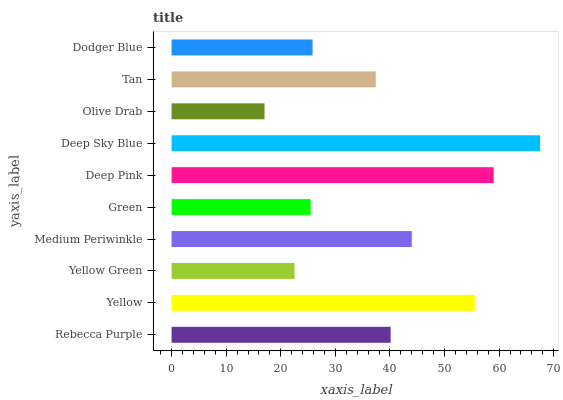Is Olive Drab the minimum?
Answer yes or no. Yes. Is Deep Sky Blue the maximum?
Answer yes or no. Yes. Is Yellow the minimum?
Answer yes or no. No. Is Yellow the maximum?
Answer yes or no. No. Is Yellow greater than Rebecca Purple?
Answer yes or no. Yes. Is Rebecca Purple less than Yellow?
Answer yes or no. Yes. Is Rebecca Purple greater than Yellow?
Answer yes or no. No. Is Yellow less than Rebecca Purple?
Answer yes or no. No. Is Rebecca Purple the high median?
Answer yes or no. Yes. Is Tan the low median?
Answer yes or no. Yes. Is Tan the high median?
Answer yes or no. No. Is Rebecca Purple the low median?
Answer yes or no. No. 